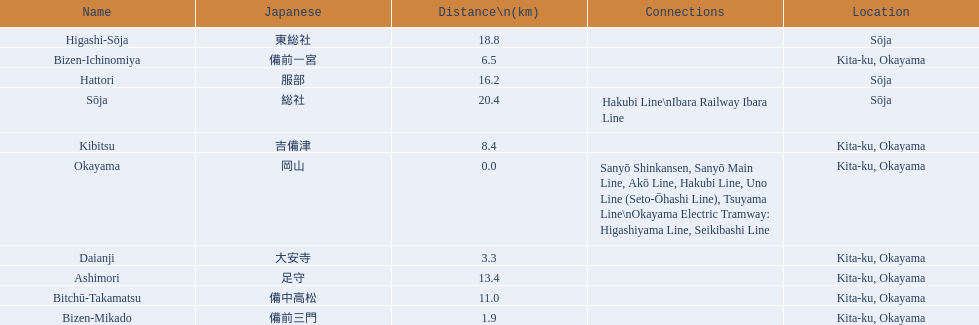What are all of the train names? Okayama, Bizen-Mikado, Daianji, Bizen-Ichinomiya, Kibitsu, Bitchū-Takamatsu, Ashimori, Hattori, Higashi-Sōja, Sōja. What is the distance for each? 0.0, 1.9, 3.3, 6.5, 8.4, 11.0, 13.4, 16.2, 18.8, 20.4. And which train's distance is between 1 and 2 km? Bizen-Mikado. 